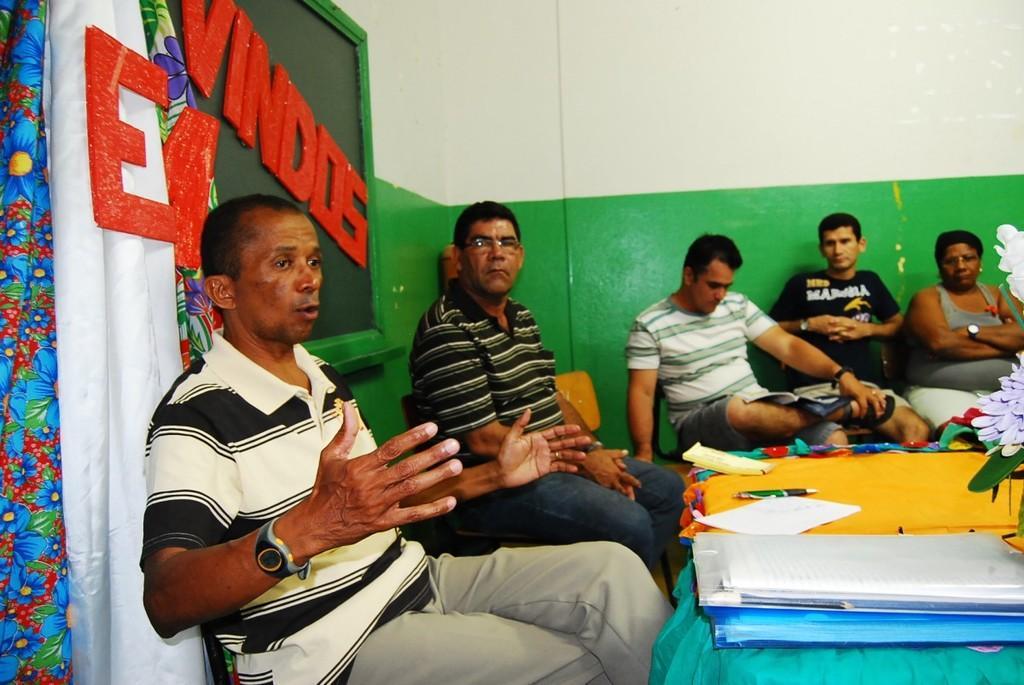Can you describe this image briefly? This people are sitting on a chair. In-front of them there is a table, on table there are files, paper and pen. This is a blackboard. This are curtains. Wall is in white and green color. 